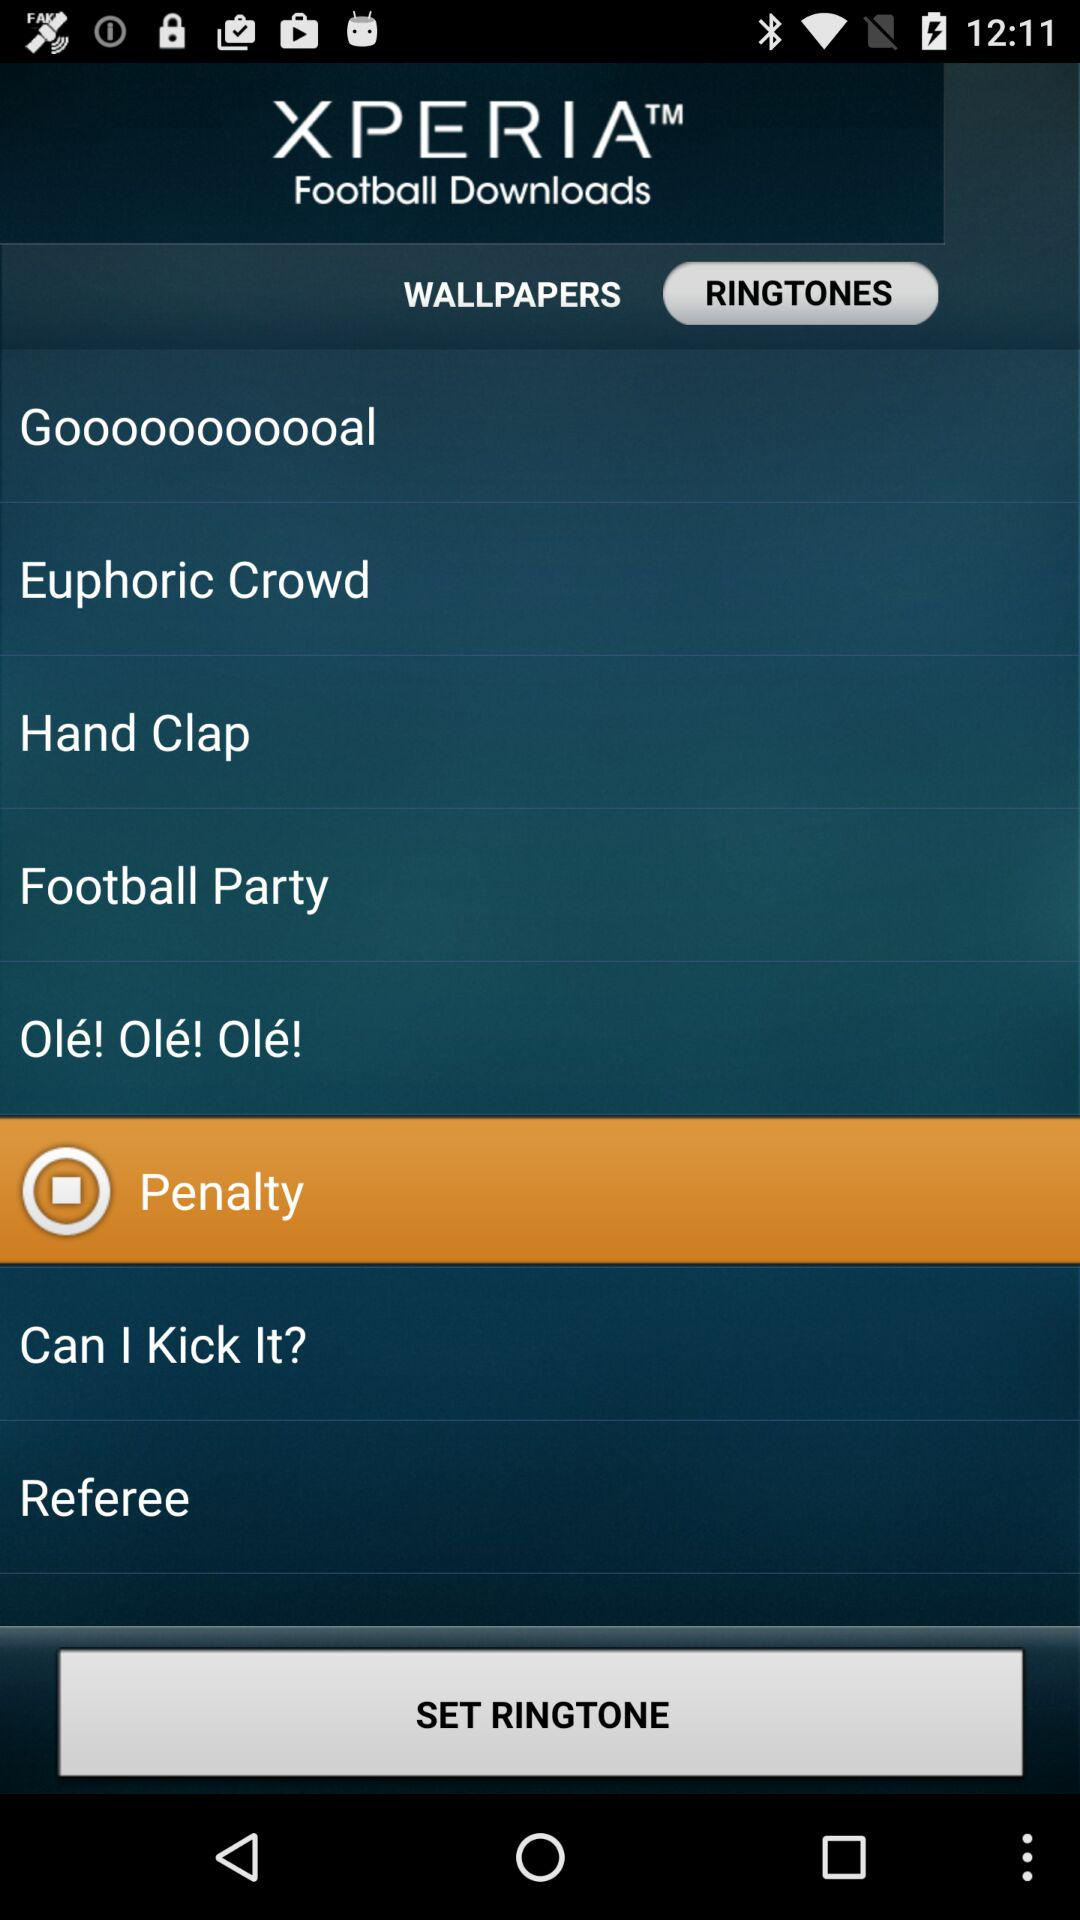Which ringtone is selected? The selected ringtone is "Penalty". 